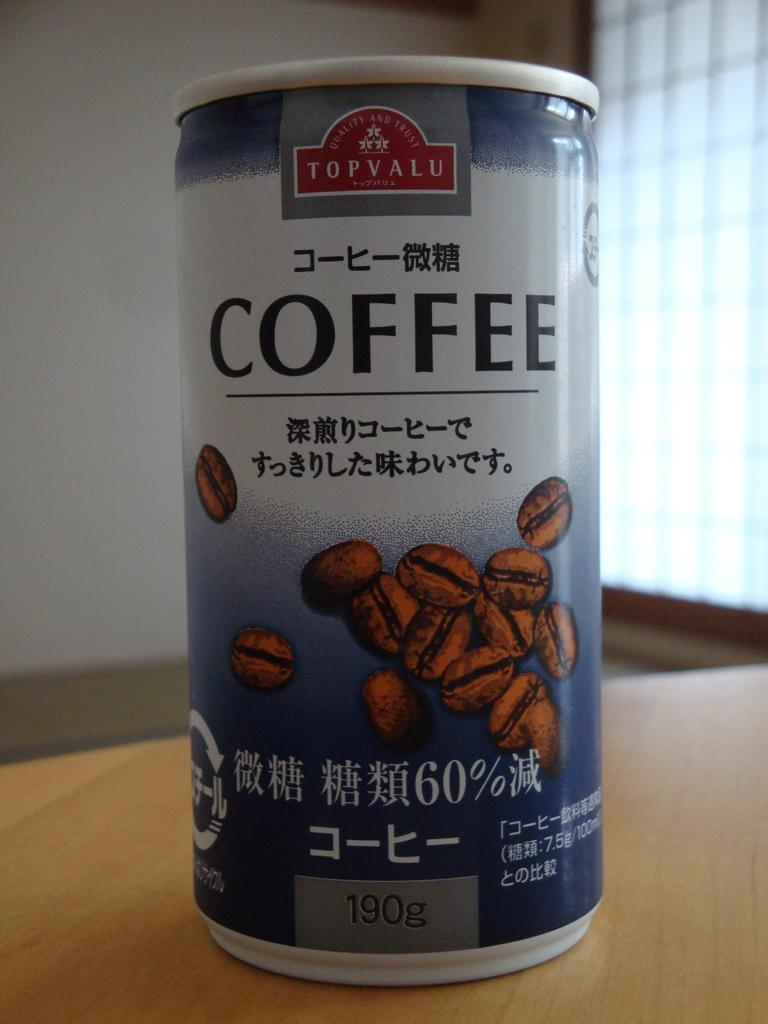Provide a one-sentence caption for the provided image. A can of Topvalu coffee with images of coffee beans on it. 